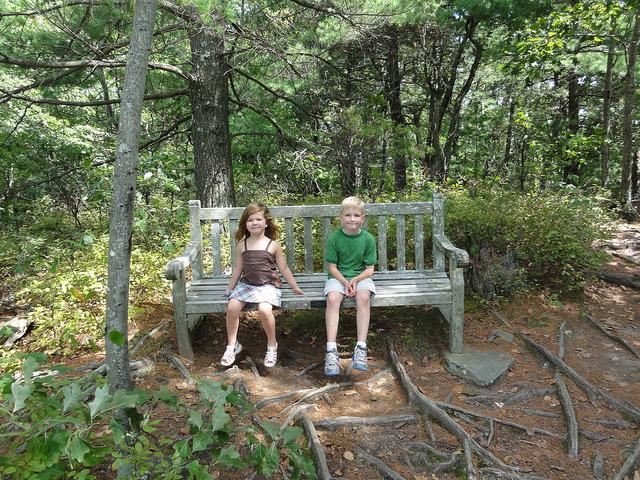What could likely happen to you on this bench? get pictured 